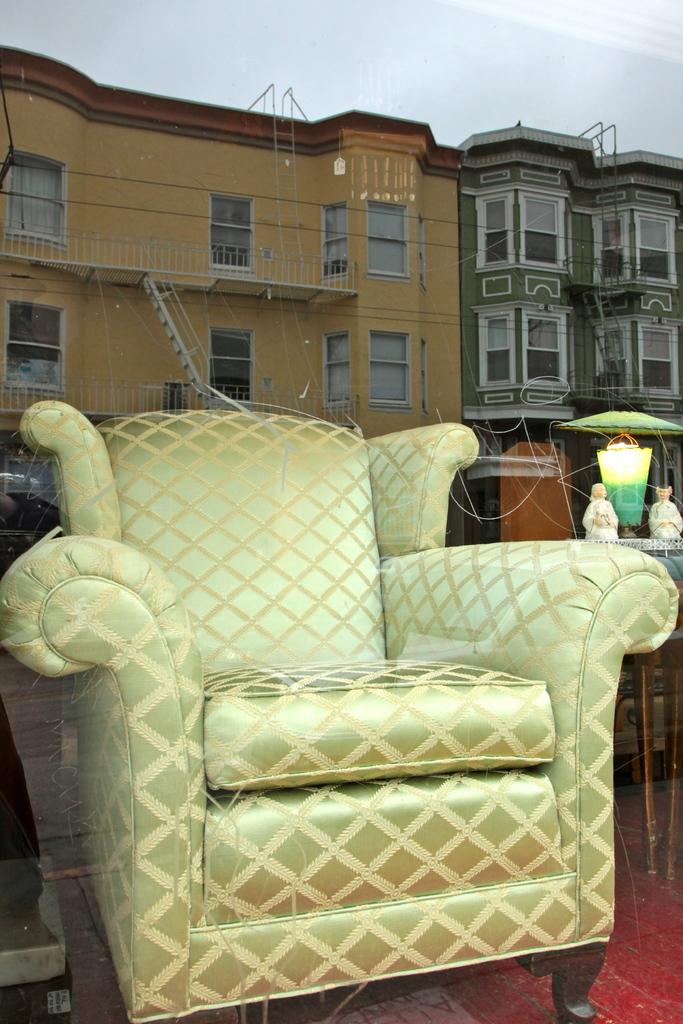What type of furniture is present in the image? There is a sofa in the image. What is located beside the sofa? There is a lamp beside the sofa. What can be seen in the reflection of the image? There is a reflection of a building in the image. What else can be seen in the image besides the reflection? There are other buildings visible in the image. How would you describe the weather based on the image? The sky is clear in the image, suggesting good weather. Where is the queen sitting in the image? There is no queen present in the image. Which direction is north in the image? The image does not provide any information about the direction of north. 